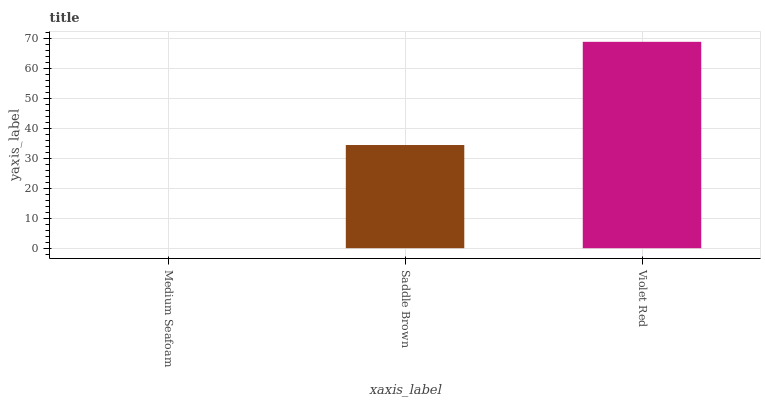Is Medium Seafoam the minimum?
Answer yes or no. Yes. Is Violet Red the maximum?
Answer yes or no. Yes. Is Saddle Brown the minimum?
Answer yes or no. No. Is Saddle Brown the maximum?
Answer yes or no. No. Is Saddle Brown greater than Medium Seafoam?
Answer yes or no. Yes. Is Medium Seafoam less than Saddle Brown?
Answer yes or no. Yes. Is Medium Seafoam greater than Saddle Brown?
Answer yes or no. No. Is Saddle Brown less than Medium Seafoam?
Answer yes or no. No. Is Saddle Brown the high median?
Answer yes or no. Yes. Is Saddle Brown the low median?
Answer yes or no. Yes. Is Violet Red the high median?
Answer yes or no. No. Is Medium Seafoam the low median?
Answer yes or no. No. 